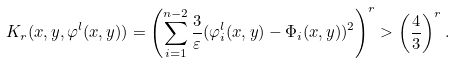<formula> <loc_0><loc_0><loc_500><loc_500>K _ { r } ( x , y , \varphi ^ { l } ( x , y ) ) = \left ( \sum _ { i = 1 } ^ { n - 2 } \frac { 3 } { \varepsilon } ( \varphi _ { i } ^ { l } ( x , y ) - \Phi _ { i } ( x , y ) ) ^ { 2 } \right ) ^ { r } > \left ( \frac { 4 } { 3 } \right ) ^ { r } .</formula> 